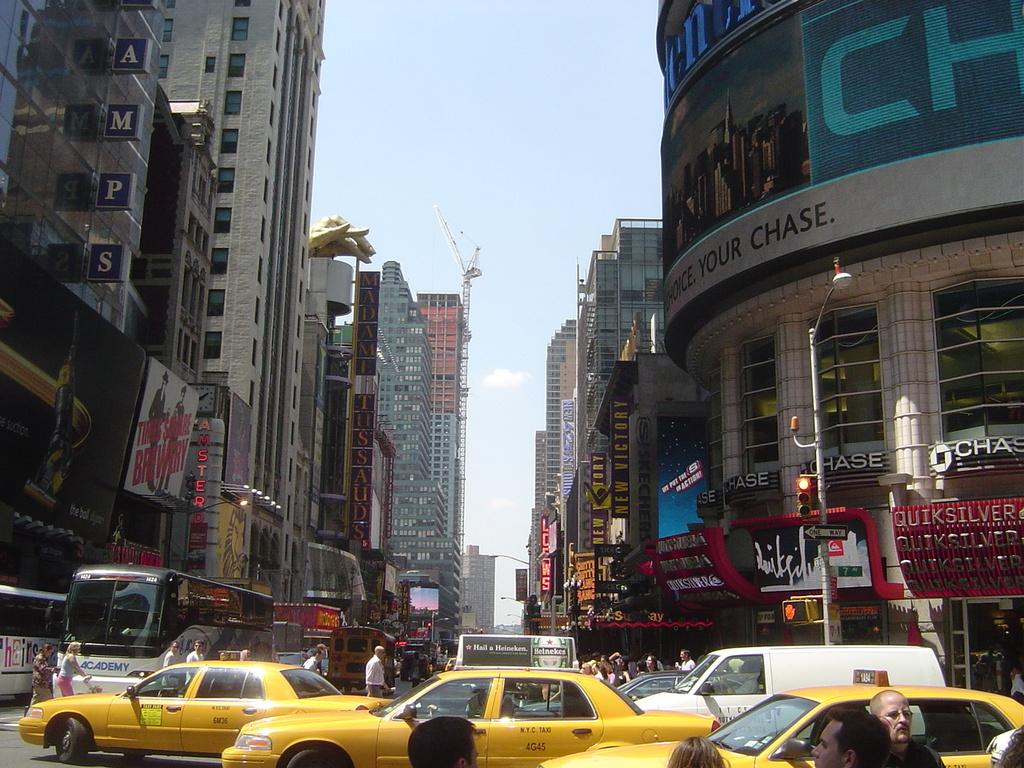Provide a one-sentence caption for the provided image. A busy downtown street with a Chase bank on the righthand side. 